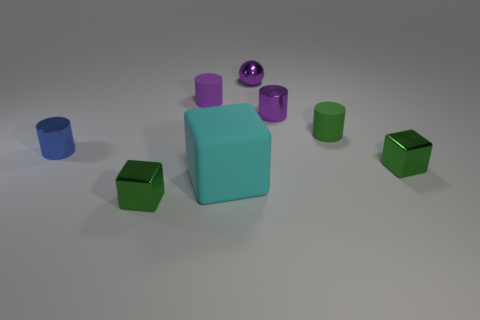Is the number of blue objects that are on the right side of the ball the same as the number of big cyan blocks right of the small green rubber cylinder?
Offer a very short reply. Yes. Is there a thing?
Your answer should be very brief. Yes. What size is the other metallic thing that is the same shape as the blue shiny thing?
Your answer should be very brief. Small. What is the size of the object that is to the right of the small green matte cylinder?
Offer a very short reply. Small. Is the number of large blocks on the left side of the purple metal cylinder greater than the number of large cyan rubber things?
Give a very brief answer. No. What shape is the cyan thing?
Your answer should be compact. Cube. Do the tiny rubber object that is to the left of the large cyan thing and the tiny metallic cylinder that is in front of the green matte cylinder have the same color?
Make the answer very short. No. Do the big rubber object and the green matte thing have the same shape?
Provide a succinct answer. No. Are there any other things that have the same shape as the purple matte thing?
Your answer should be very brief. Yes. Are the cube behind the cyan block and the tiny purple sphere made of the same material?
Your answer should be very brief. Yes. 